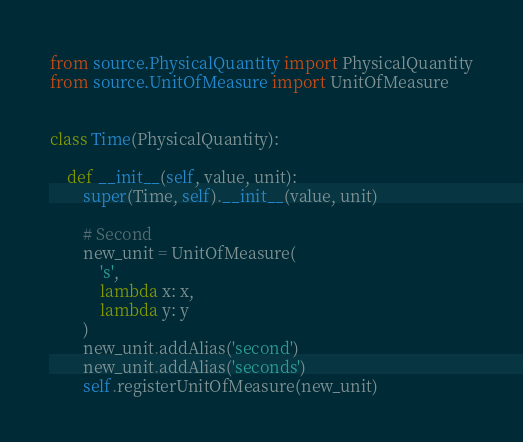<code> <loc_0><loc_0><loc_500><loc_500><_Python_>from source.PhysicalQuantity import PhysicalQuantity
from source.UnitOfMeasure import UnitOfMeasure


class Time(PhysicalQuantity):

    def __init__(self, value, unit):
        super(Time, self).__init__(value, unit)

        # Second
        new_unit = UnitOfMeasure(
            's',
            lambda x: x,
            lambda y: y
        )
        new_unit.addAlias('second')
        new_unit.addAlias('seconds')
        self.registerUnitOfMeasure(new_unit)
</code> 